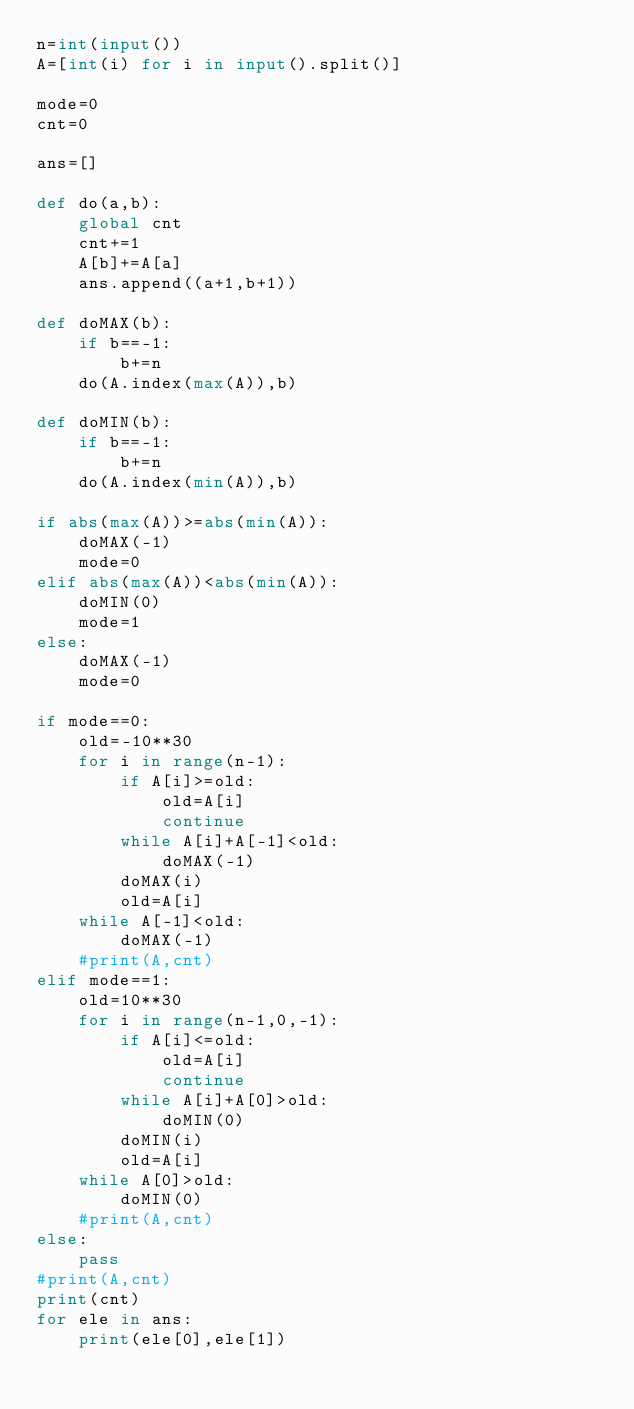Convert code to text. <code><loc_0><loc_0><loc_500><loc_500><_Python_>n=int(input())
A=[int(i) for i in input().split()]

mode=0
cnt=0

ans=[]

def do(a,b):
    global cnt
    cnt+=1
    A[b]+=A[a]
    ans.append((a+1,b+1))

def doMAX(b):
    if b==-1:
        b+=n
    do(A.index(max(A)),b)

def doMIN(b):
    if b==-1:
        b+=n
    do(A.index(min(A)),b)

if abs(max(A))>=abs(min(A)):
    doMAX(-1)
    mode=0
elif abs(max(A))<abs(min(A)):
    doMIN(0)
    mode=1
else:
    doMAX(-1)
    mode=0

if mode==0:
    old=-10**30
    for i in range(n-1):
        if A[i]>=old:
            old=A[i]
            continue
        while A[i]+A[-1]<old:
            doMAX(-1)
        doMAX(i)
        old=A[i]
    while A[-1]<old:
        doMAX(-1)
    #print(A,cnt)
elif mode==1:
    old=10**30
    for i in range(n-1,0,-1):
        if A[i]<=old:
            old=A[i]
            continue
        while A[i]+A[0]>old:
            doMIN(0)
        doMIN(i)
        old=A[i]
    while A[0]>old:
        doMIN(0)
    #print(A,cnt)
else:
    pass
#print(A,cnt)
print(cnt)
for ele in ans:
    print(ele[0],ele[1])
    </code> 